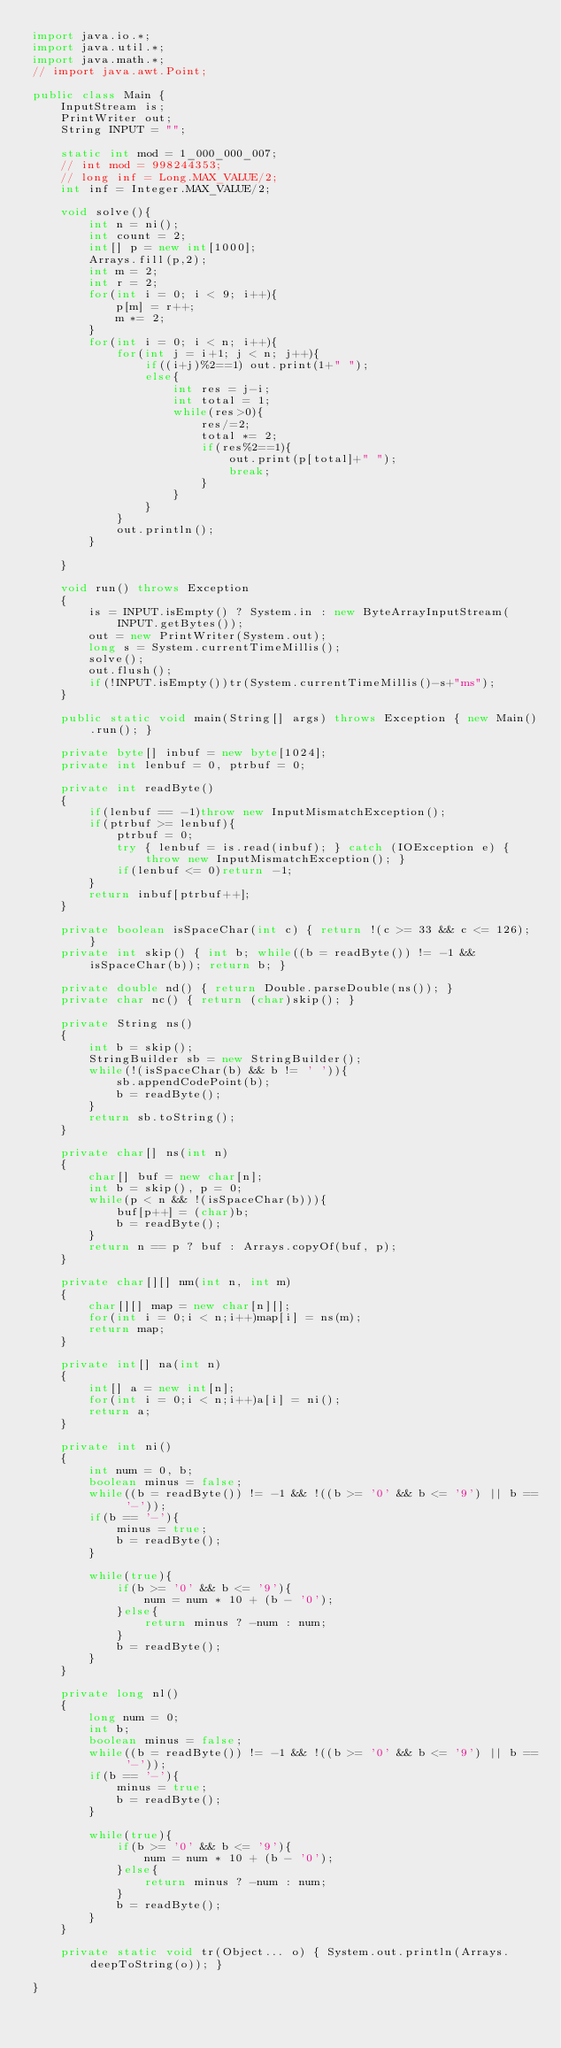<code> <loc_0><loc_0><loc_500><loc_500><_Java_>import java.io.*;
import java.util.*;
import java.math.*;
// import java.awt.Point;
 
public class Main {
    InputStream is;
    PrintWriter out;
    String INPUT = "";
 
    static int mod = 1_000_000_007;
    // int mod = 998244353;
    // long inf = Long.MAX_VALUE/2;
    int inf = Integer.MAX_VALUE/2;

    void solve(){
        int n = ni();
        int count = 2;
        int[] p = new int[1000];
        Arrays.fill(p,2);
        int m = 2;
        int r = 2;
        for(int i = 0; i < 9; i++){
            p[m] = r++;
            m *= 2;
        }
        for(int i = 0; i < n; i++){
            for(int j = i+1; j < n; j++){
                if((i+j)%2==1) out.print(1+" ");
                else{
                    int res = j-i;
                    int total = 1;
                    while(res>0){
                        res/=2;
                        total *= 2;
                        if(res%2==1){
                            out.print(p[total]+" ");
                            break;
                        }
                    }
                }
            }
            out.println();
        }

    }

    void run() throws Exception
    {
        is = INPUT.isEmpty() ? System.in : new ByteArrayInputStream(INPUT.getBytes());
        out = new PrintWriter(System.out);
        long s = System.currentTimeMillis();
        solve();
        out.flush();
        if(!INPUT.isEmpty())tr(System.currentTimeMillis()-s+"ms");
    }
    
    public static void main(String[] args) throws Exception { new Main().run(); }
    
    private byte[] inbuf = new byte[1024];
    private int lenbuf = 0, ptrbuf = 0;
    
    private int readByte()
    {
        if(lenbuf == -1)throw new InputMismatchException();
        if(ptrbuf >= lenbuf){
            ptrbuf = 0;
            try { lenbuf = is.read(inbuf); } catch (IOException e) { throw new InputMismatchException(); }
            if(lenbuf <= 0)return -1;
        }
        return inbuf[ptrbuf++];
    }
    
    private boolean isSpaceChar(int c) { return !(c >= 33 && c <= 126); }
    private int skip() { int b; while((b = readByte()) != -1 && isSpaceChar(b)); return b; }
    
    private double nd() { return Double.parseDouble(ns()); }
    private char nc() { return (char)skip(); }
    
    private String ns()
    {
        int b = skip();
        StringBuilder sb = new StringBuilder();
        while(!(isSpaceChar(b) && b != ' ')){
            sb.appendCodePoint(b);
            b = readByte();
        }
        return sb.toString();
    }
    
    private char[] ns(int n)
    {
        char[] buf = new char[n];
        int b = skip(), p = 0;
        while(p < n && !(isSpaceChar(b))){
            buf[p++] = (char)b;
            b = readByte();
        }
        return n == p ? buf : Arrays.copyOf(buf, p);
    }
    
    private char[][] nm(int n, int m)
    {
        char[][] map = new char[n][];
        for(int i = 0;i < n;i++)map[i] = ns(m);
        return map;
    }
    
    private int[] na(int n)
    {
        int[] a = new int[n];
        for(int i = 0;i < n;i++)a[i] = ni();
        return a;
    }
    
    private int ni()
    {
        int num = 0, b;
        boolean minus = false;
        while((b = readByte()) != -1 && !((b >= '0' && b <= '9') || b == '-'));
        if(b == '-'){
            minus = true;
            b = readByte();
        }
        
        while(true){
            if(b >= '0' && b <= '9'){
                num = num * 10 + (b - '0');
            }else{
                return minus ? -num : num;
            }
            b = readByte();
        }
    }
    
    private long nl()
    {
        long num = 0;
        int b;
        boolean minus = false;
        while((b = readByte()) != -1 && !((b >= '0' && b <= '9') || b == '-'));
        if(b == '-'){
            minus = true;
            b = readByte();
        }
        
        while(true){
            if(b >= '0' && b <= '9'){
                num = num * 10 + (b - '0');
            }else{
                return minus ? -num : num;
            }
            b = readByte();
        }
    }
    
    private static void tr(Object... o) { System.out.println(Arrays.deepToString(o)); }
 
}
</code> 